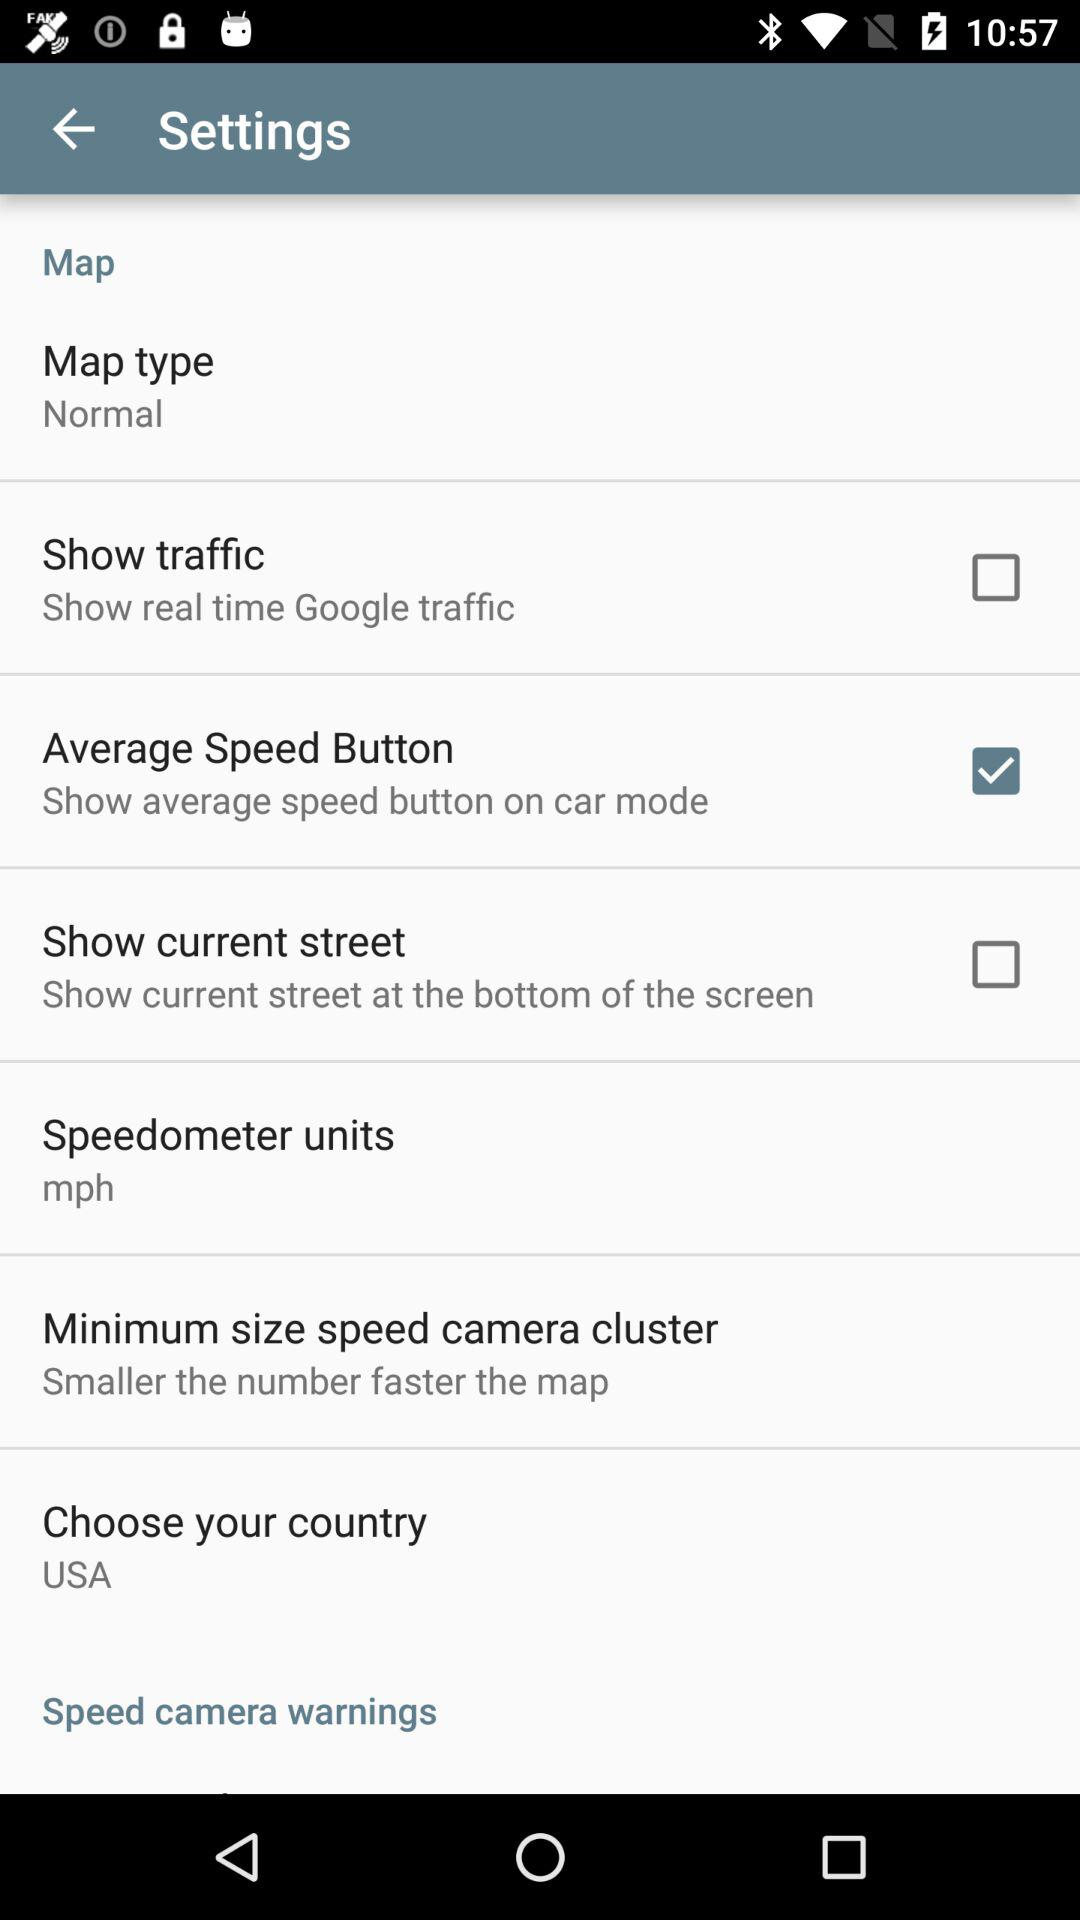What's the status of the average speed button? The status is on. 